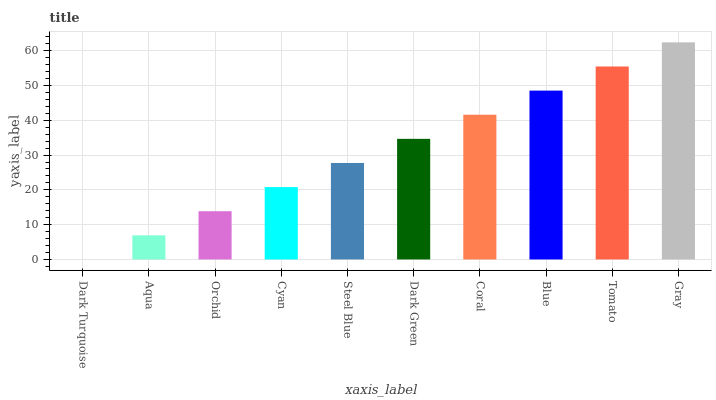Is Dark Turquoise the minimum?
Answer yes or no. Yes. Is Gray the maximum?
Answer yes or no. Yes. Is Aqua the minimum?
Answer yes or no. No. Is Aqua the maximum?
Answer yes or no. No. Is Aqua greater than Dark Turquoise?
Answer yes or no. Yes. Is Dark Turquoise less than Aqua?
Answer yes or no. Yes. Is Dark Turquoise greater than Aqua?
Answer yes or no. No. Is Aqua less than Dark Turquoise?
Answer yes or no. No. Is Dark Green the high median?
Answer yes or no. Yes. Is Steel Blue the low median?
Answer yes or no. Yes. Is Tomato the high median?
Answer yes or no. No. Is Tomato the low median?
Answer yes or no. No. 